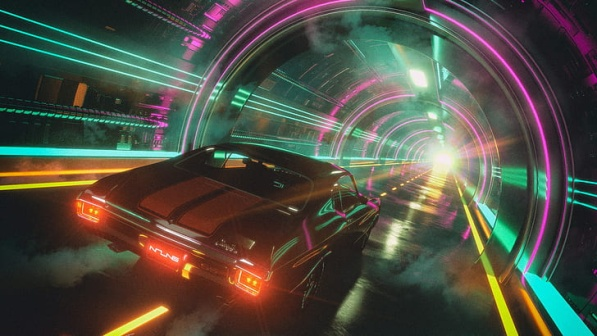What kind of story can you imagine taking place in this scene? In this vibrant futuristic setting, imagine a high-stakes chase through the neon-lit tunnels of Neo-Metropolis. A seasoned street racer named Alex drives the sleek black sports car, evading pursuit from a relentless corporate security team. Alex carries with him a data drive stolen from the corporation, containing secrets that could topple the corrupt system controlling the city. As he navigates the labyrinthine tunnels, the neon lights cast reflections and shadows that blur the lines between reality and illusion, making his escape ever more thrilling and perilous. What do you think Alex might encounter at the end of the tunnel? As Alex bursts through the tunnel's exit, he is greeted by the panoramic expanse of Neo-Metropolis’s skyline. The city's skyline is a dazzling array of towering skyscrapers with holographic advertisements and floating platforms. He enters the bustling heart of the city, filled with flying cars and bustling streets. The bright white light, previously seen at the tunnel's end, is revealed to be a giant digital billboard displaying cryptic messages that hint at the looming rebellion against the corporate overlords. In this moment, Alex realizes that his mission is just beginning, with allies waiting for him in the shadows of the city's underground resistance movement. 